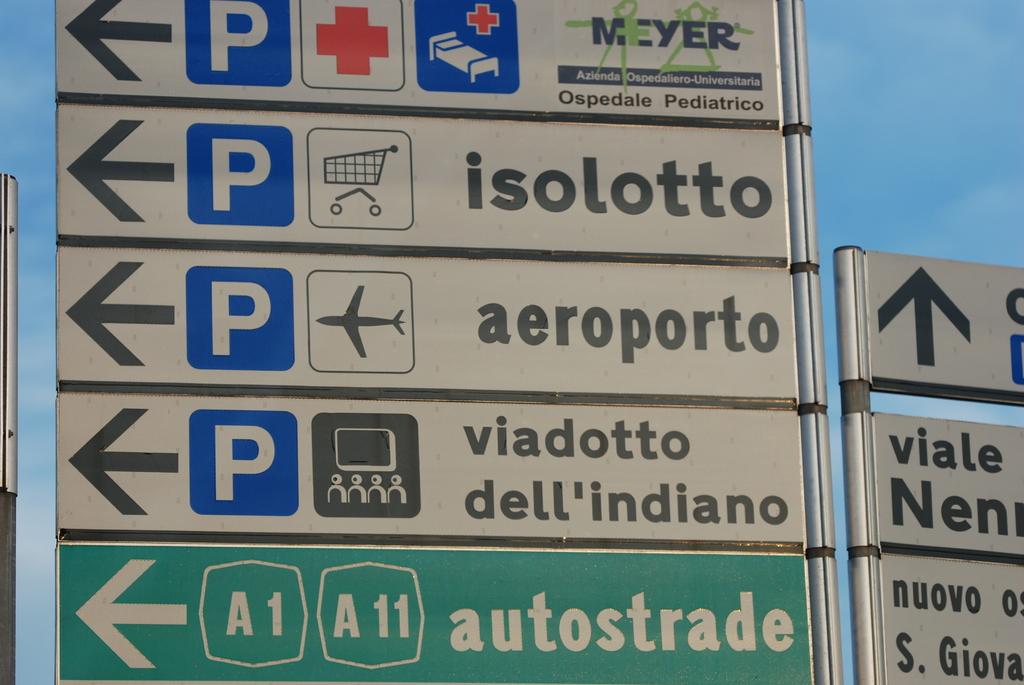What is found if following the sign with an airplane image?
Offer a very short reply. Aeroporto. 